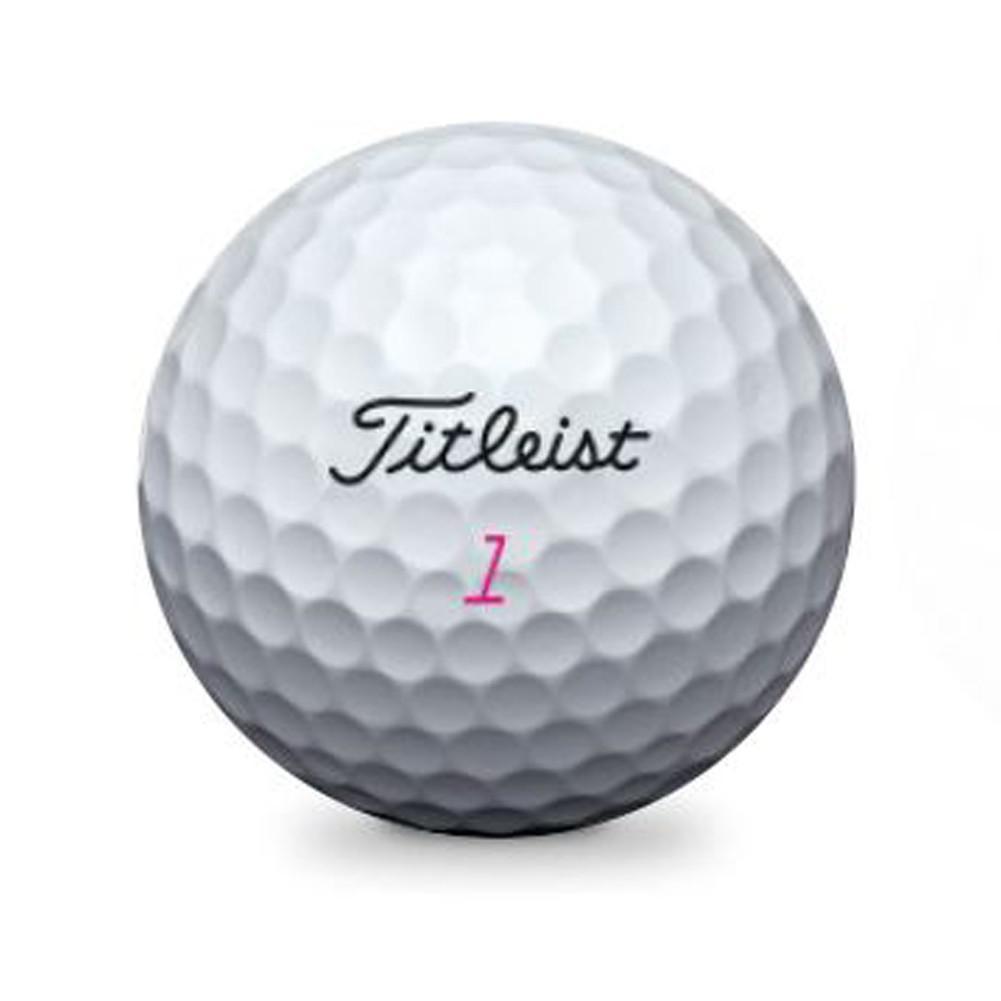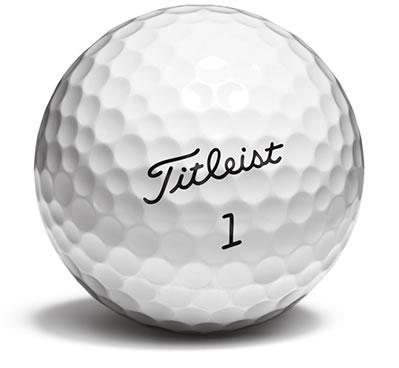The first image is the image on the left, the second image is the image on the right. Considering the images on both sides, is "There is not less than one golf ball resting on a tee" valid? Answer yes or no. No. 